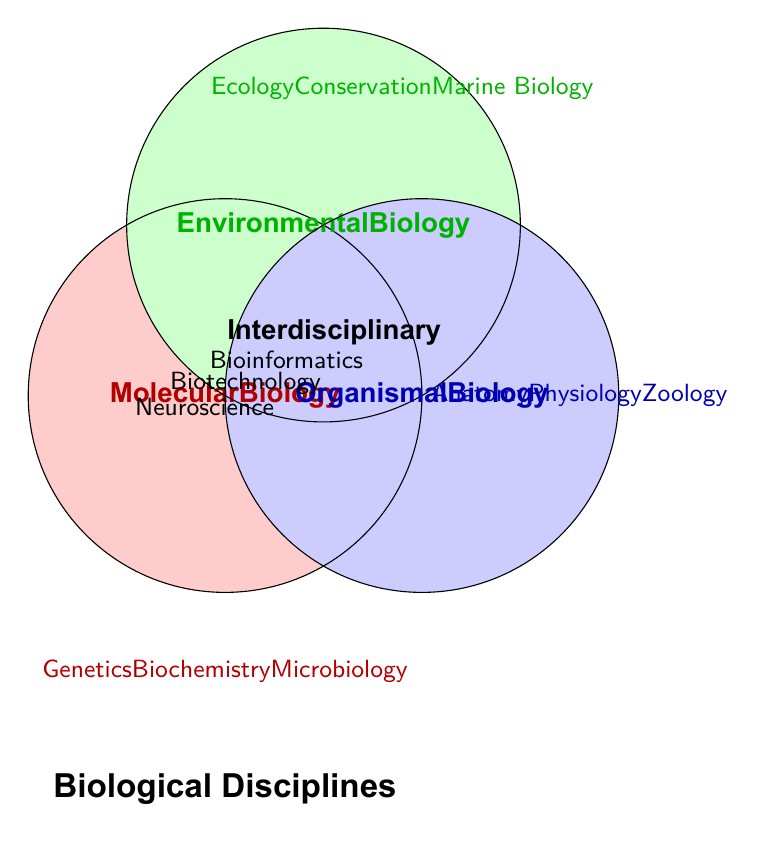What's the title of the figure? The title is written at the bottom center of the figure.
Answer: Biological Disciplines Which disciplines fall under Molecular Biology? Look under the "Molecular Biology" section on the left for the list of disciplines.
Answer: Genetics, Biochemistry, Microbiology How many disciplines are listed under Environmental Biology? Count the number of disciplines listed under "Environmental Biology" on the top right.
Answer: 3 What categories fall under Interdisciplinary? Identify the list of categories within the "Interdisciplinary" section.
Answer: Bioinformatics, Biotechnology, Neuroscience Which category is found in the intersection of all three Venn diagram circles? Look for the section where all three circles overlap and note the discipline listed.
Answer: Interdisciplinary Which category contains Zoology? Look at the list of disciplines within "Organismal Biology".
Answer: Organismal Biology Are there more disciplines in Molecular Biology or Environmental Biology? Compare the number of disciplines listed under Molecular Biology and Environmental Biology.
Answer: Molecular Biology Which disciplines fall into more than one category? Identify any discipline that appears in overlapping sections of the Venn diagram circles.
Answer: Interdisciplinary disciplines (Bioinformatics, Biotechnology, Neuroscience) Name one discipline that falls under Organismal Biology. Look at the list of disciplines under the "Organismal Biology" section.
Answer: Anatomy, Physiology, or Zoology Which discipline does not belong to Molecular, Environmental, or Organismal Biology exclusively? Identify the category listed in the overlapping (center) section of all three circles.
Answer: Interdisciplinary 